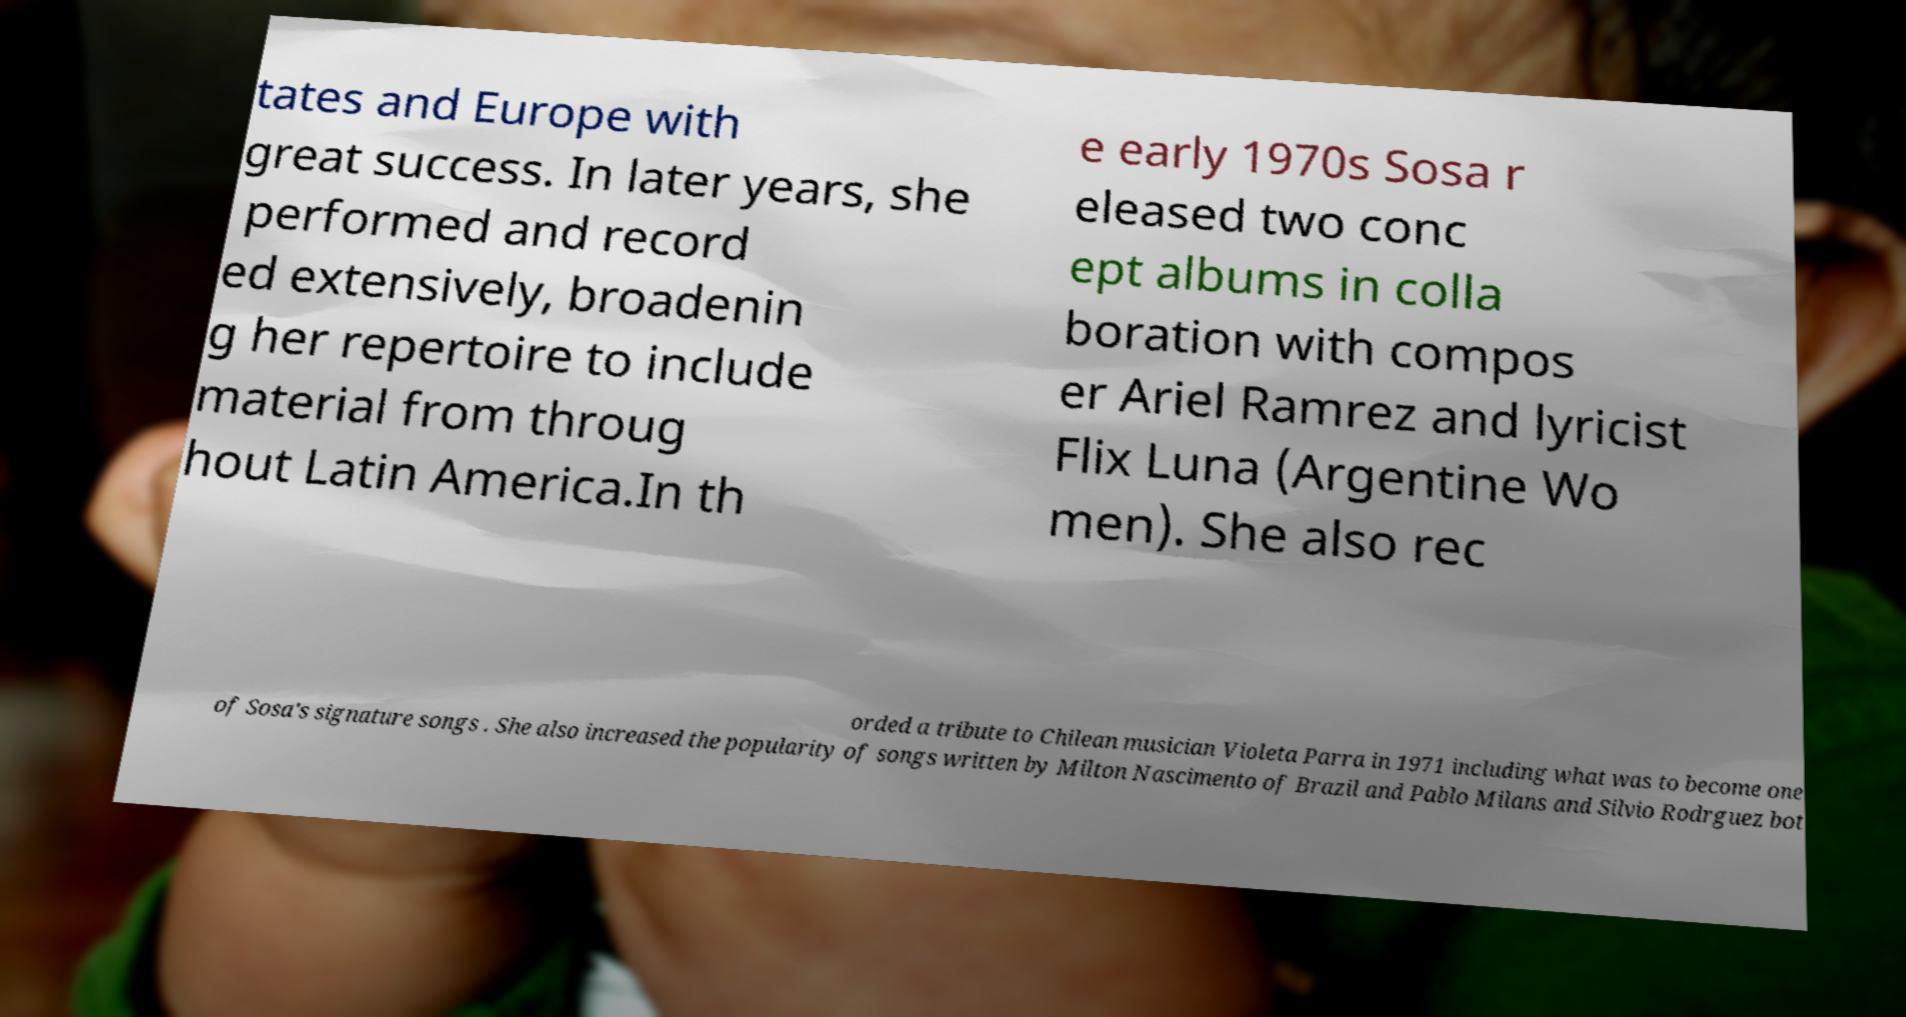There's text embedded in this image that I need extracted. Can you transcribe it verbatim? tates and Europe with great success. In later years, she performed and record ed extensively, broadenin g her repertoire to include material from throug hout Latin America.In th e early 1970s Sosa r eleased two conc ept albums in colla boration with compos er Ariel Ramrez and lyricist Flix Luna (Argentine Wo men). She also rec orded a tribute to Chilean musician Violeta Parra in 1971 including what was to become one of Sosa's signature songs . She also increased the popularity of songs written by Milton Nascimento of Brazil and Pablo Milans and Silvio Rodrguez bot 